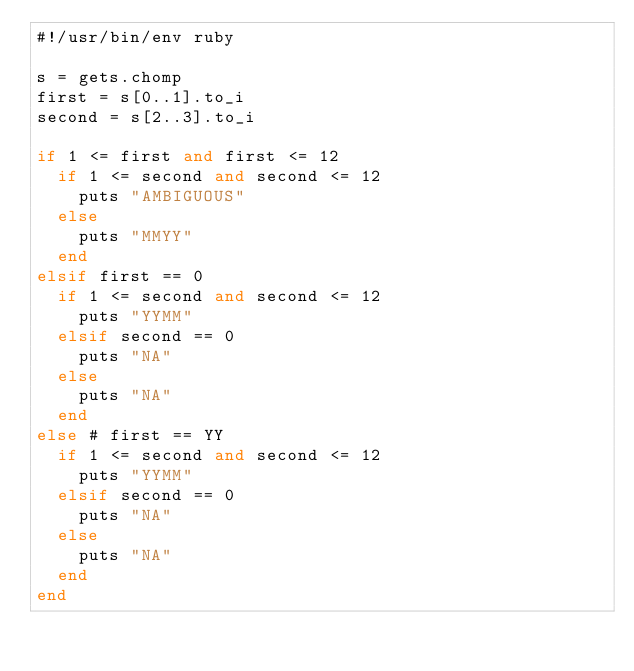Convert code to text. <code><loc_0><loc_0><loc_500><loc_500><_Ruby_>#!/usr/bin/env ruby

s = gets.chomp
first = s[0..1].to_i
second = s[2..3].to_i

if 1 <= first and first <= 12
  if 1 <= second and second <= 12
    puts "AMBIGUOUS"
  else
    puts "MMYY"
  end
elsif first == 0
  if 1 <= second and second <= 12
    puts "YYMM"
  elsif second == 0
    puts "NA"
  else
    puts "NA"
  end
else # first == YY
  if 1 <= second and second <= 12
    puts "YYMM"
  elsif second == 0
    puts "NA"
  else
    puts "NA"
  end
end
</code> 